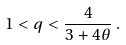Convert formula to latex. <formula><loc_0><loc_0><loc_500><loc_500>1 < q < \frac { 4 } { 3 + 4 \theta } \, .</formula> 